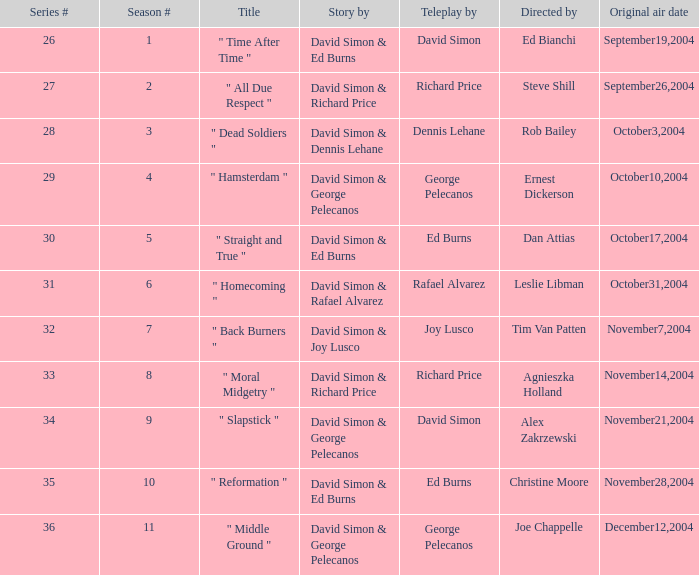Could you help me parse every detail presented in this table? {'header': ['Series #', 'Season #', 'Title', 'Story by', 'Teleplay by', 'Directed by', 'Original air date'], 'rows': [['26', '1', '" Time After Time "', 'David Simon & Ed Burns', 'David Simon', 'Ed Bianchi', 'September19,2004'], ['27', '2', '" All Due Respect "', 'David Simon & Richard Price', 'Richard Price', 'Steve Shill', 'September26,2004'], ['28', '3', '" Dead Soldiers "', 'David Simon & Dennis Lehane', 'Dennis Lehane', 'Rob Bailey', 'October3,2004'], ['29', '4', '" Hamsterdam "', 'David Simon & George Pelecanos', 'George Pelecanos', 'Ernest Dickerson', 'October10,2004'], ['30', '5', '" Straight and True "', 'David Simon & Ed Burns', 'Ed Burns', 'Dan Attias', 'October17,2004'], ['31', '6', '" Homecoming "', 'David Simon & Rafael Alvarez', 'Rafael Alvarez', 'Leslie Libman', 'October31,2004'], ['32', '7', '" Back Burners "', 'David Simon & Joy Lusco', 'Joy Lusco', 'Tim Van Patten', 'November7,2004'], ['33', '8', '" Moral Midgetry "', 'David Simon & Richard Price', 'Richard Price', 'Agnieszka Holland', 'November14,2004'], ['34', '9', '" Slapstick "', 'David Simon & George Pelecanos', 'David Simon', 'Alex Zakrzewski', 'November21,2004'], ['35', '10', '" Reformation "', 'David Simon & Ed Burns', 'Ed Burns', 'Christine Moore', 'November28,2004'], ['36', '11', '" Middle Ground "', 'David Simon & George Pelecanos', 'George Pelecanos', 'Joe Chappelle', 'December12,2004']]} For series #35, how many values are there in the "teleplay by" category? 1.0. 